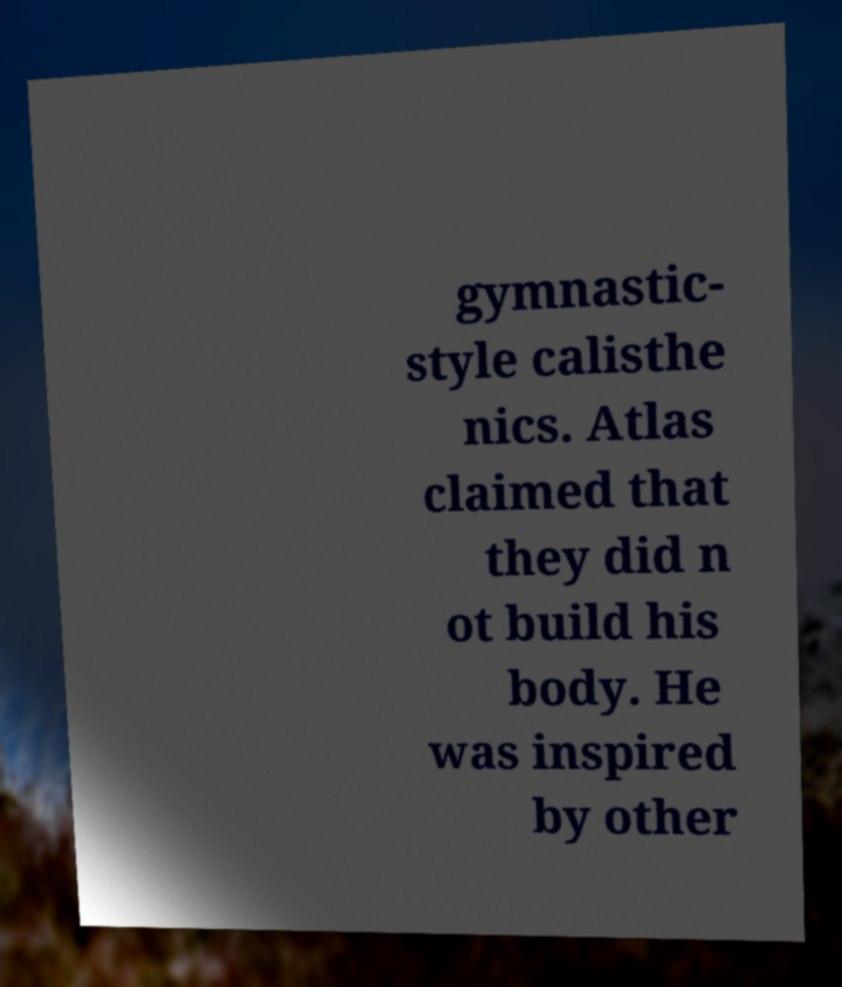Please read and relay the text visible in this image. What does it say? gymnastic- style calisthe nics. Atlas claimed that they did n ot build his body. He was inspired by other 